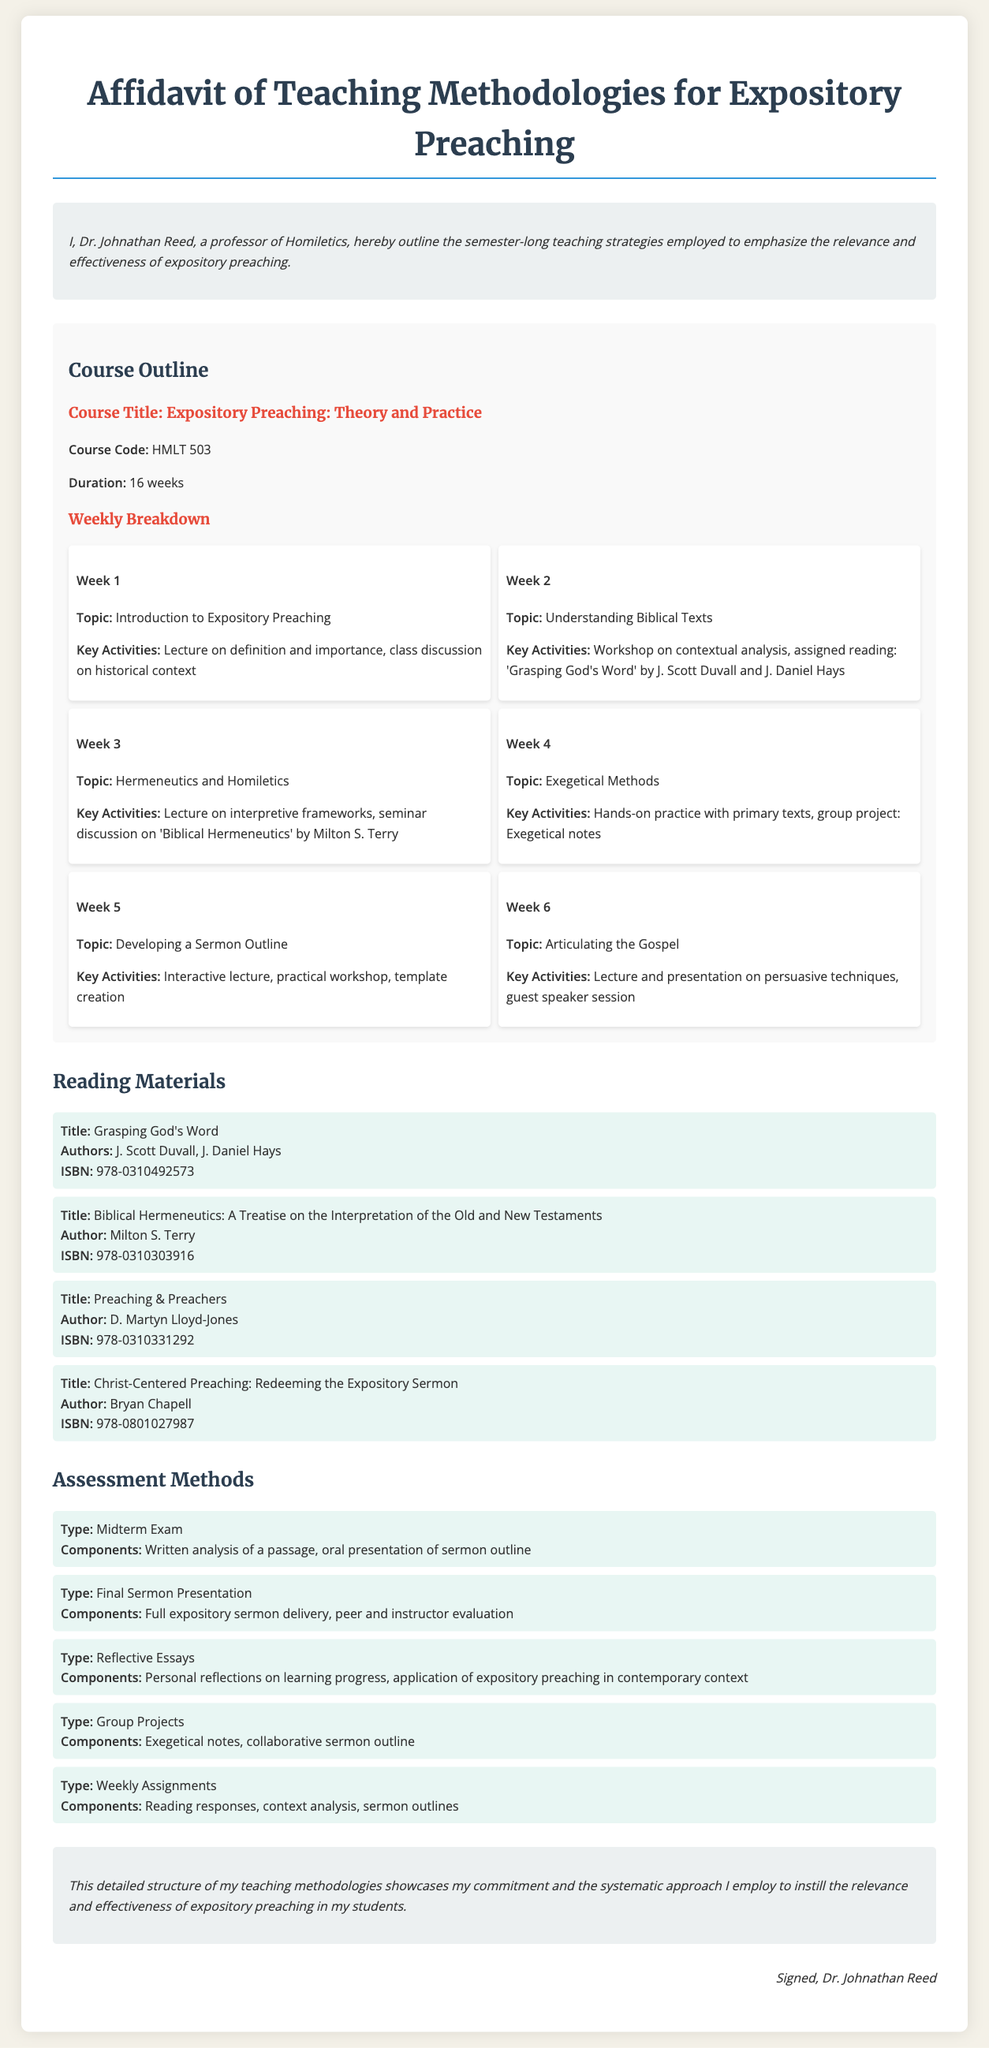What is the course code for Expository Preaching? The course code is specified in the course outline section of the document.
Answer: HMLT 503 Who is the author of "Grasping God's Word"? The author is listed in the reading materials section of the document.
Answer: J. Scott Duvall What type of assessment is the Final Sermon Presentation? The type of assessment is mentioned under the assessment methods section.
Answer: Final Sermon Presentation What is the duration of the course? The duration of the course is stated in the course outline section.
Answer: 16 weeks What is the topic of Week 3? The topic for Week 3 is found in the weekly breakdown of the course outline.
Answer: Hermeneutics and Homiletics Which reading material has the ISBN 978-0310303916? The ISBN is provided in the reading materials section, specifying the associated title.
Answer: Biblical Hermeneutics: A Treatise on the Interpretation of the Old and New Testaments Which week focuses on Developing a Sermon Outline? The weekly topic is detailed in the course outline and corresponds to a specific week.
Answer: Week 5 What is the name of the professor? The professor's name is included in the introduction section of the document.
Answer: Dr. Johnathan Reed 